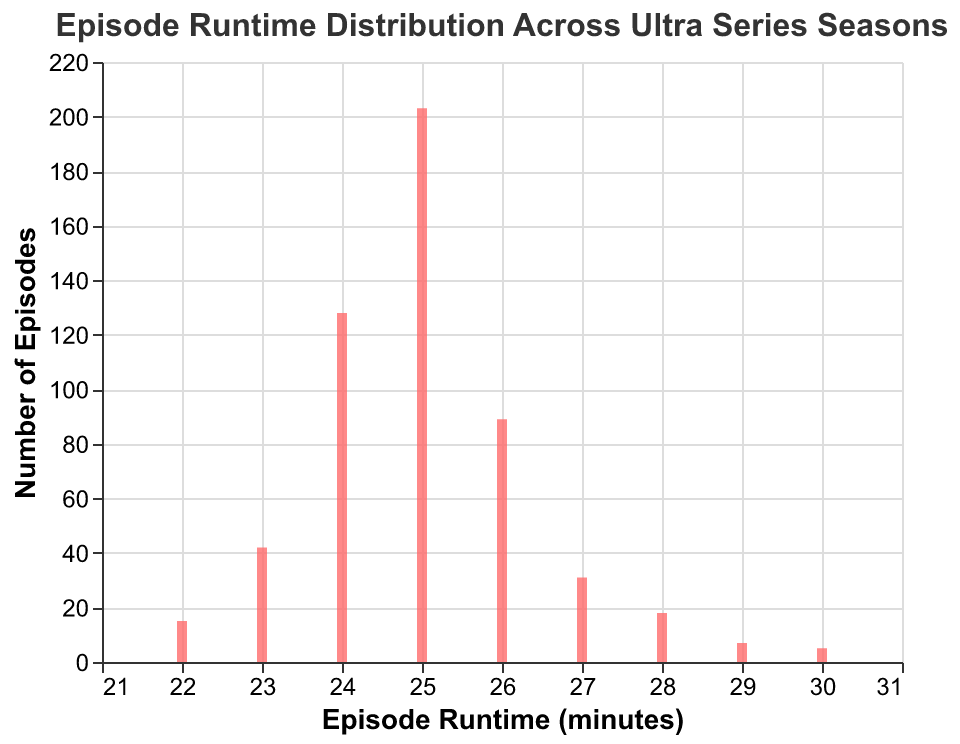What is the title of the figure? The title of the figure is located at the top and reads "Episode Runtime Distribution Across Ultra Series Seasons."
Answer: Episode Runtime Distribution Across Ultra Series Seasons What is the most frequent episode runtime in the Ultra Series seasons? To find the most frequent episode runtime, look at the bar with the highest value on the y-axis. The runtime corresponding to this highest bar is the most frequent.
Answer: 25 minutes How many episodes have a runtime of 24 minutes? Find the bar labeled with an episode runtime of 24 minutes on the x-axis and look up its height on the y-axis to determine the frequency.
Answer: 128 How does the number of episodes with a runtime of 26 minutes compare to that of 27 minutes? Compare the heights of the bars for episode runtimes of 26 minutes and 27 minutes on the y-axis to see which is taller. The taller bar represents the higher frequency.
Answer: 26 minutes has more episodes What is the total number of episodes represented in the histogram? Add up the frequencies of all episode runtimes: 15 + 42 + 128 + 203 + 89 + 31 + 18 + 7 + 5 = 538
Answer: 538 What is the least frequent episode runtime? The least frequent episode runtime will be the bar with the smallest height on the y-axis.
Answer: 30 minutes What is the combined number of episodes with runtimes of 22 and 23 minutes? Add the frequencies of the bars for episode runtimes of 22 minutes and 23 minutes: 15 + 42 = 57
Answer: 57 How many more episodes have a runtime of 25 minutes compared to 26 minutes? Subtract the frequency of episodes with a runtime of 26 minutes from those with a runtime of 25 minutes: 203 - 89 = 114
Answer: 114 What runtime category has close to half the episodes of the 25-minute runtime? Determine half the frequency of the 25-minute runtime episodes: 203 / 2 = 101.5. Look for a runtime category with a frequency close to this value.
Answer: 26 minutes How does the frequency of the 28-minute runtime compare to the frequency of the 22-minute runtime? Compare the heights of the bars for episode runtimes of 28 minutes and 22 minutes on the y-axis to determine which is taller.
Answer: 28 minutes is more frequent 